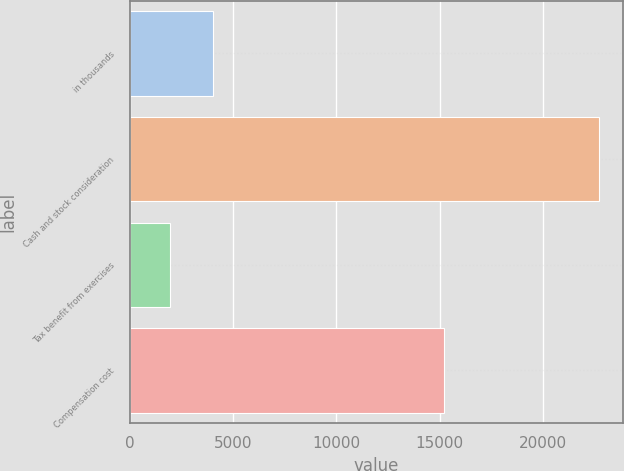Convert chart to OTSL. <chart><loc_0><loc_0><loc_500><loc_500><bar_chart><fcel>in thousands<fcel>Cash and stock consideration<fcel>Tax benefit from exercises<fcel>Compensation cost<nl><fcel>4040.4<fcel>22719<fcel>1965<fcel>15195<nl></chart> 